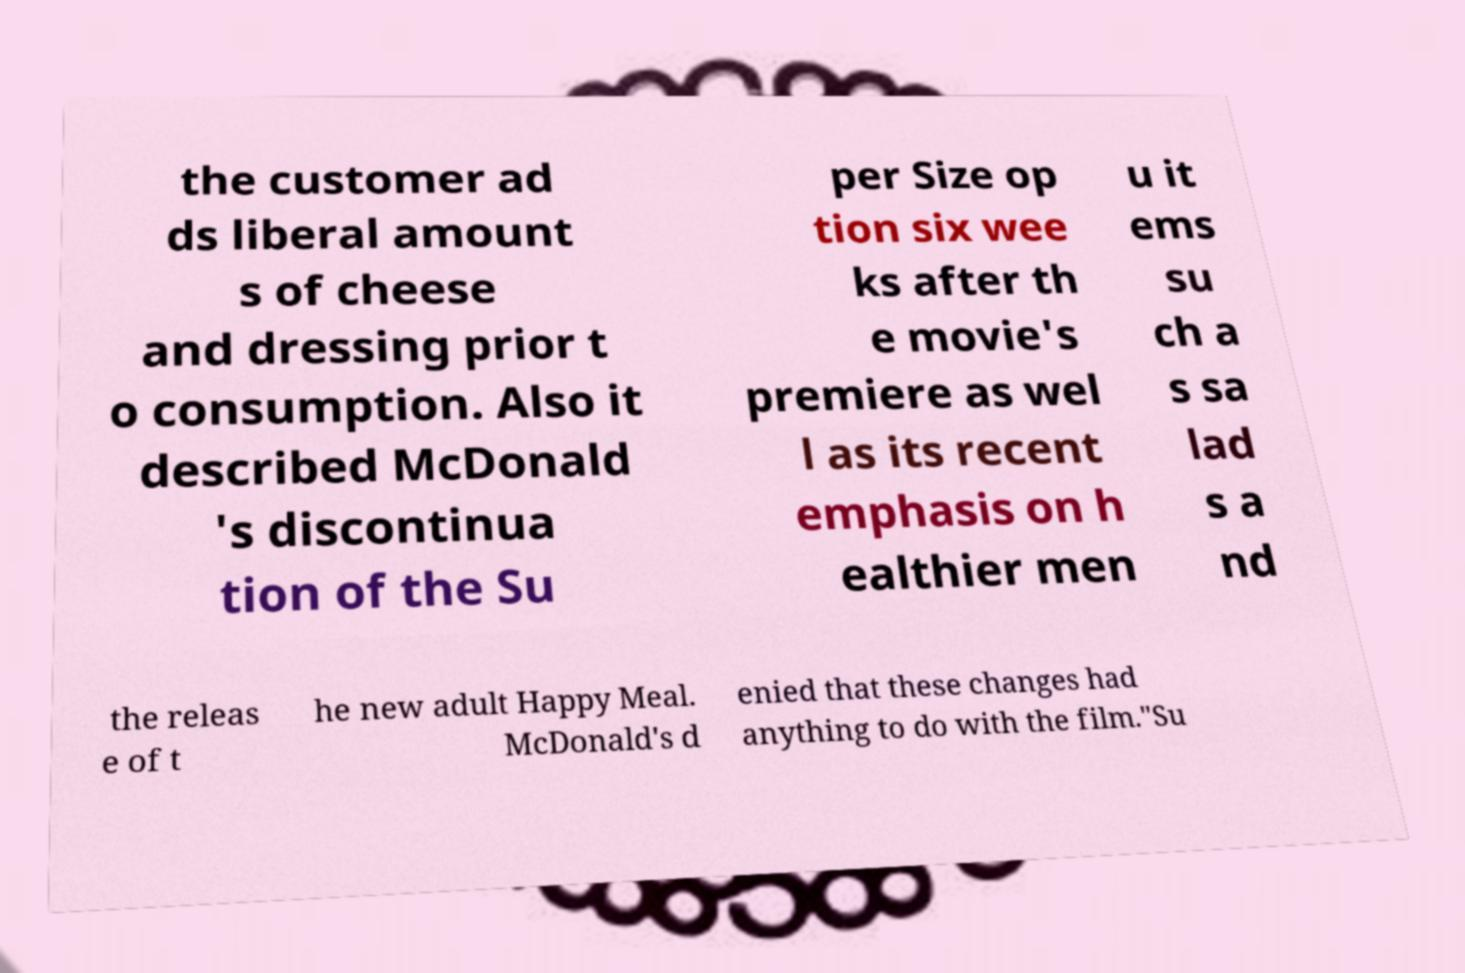I need the written content from this picture converted into text. Can you do that? the customer ad ds liberal amount s of cheese and dressing prior t o consumption. Also it described McDonald 's discontinua tion of the Su per Size op tion six wee ks after th e movie's premiere as wel l as its recent emphasis on h ealthier men u it ems su ch a s sa lad s a nd the releas e of t he new adult Happy Meal. McDonald's d enied that these changes had anything to do with the film."Su 